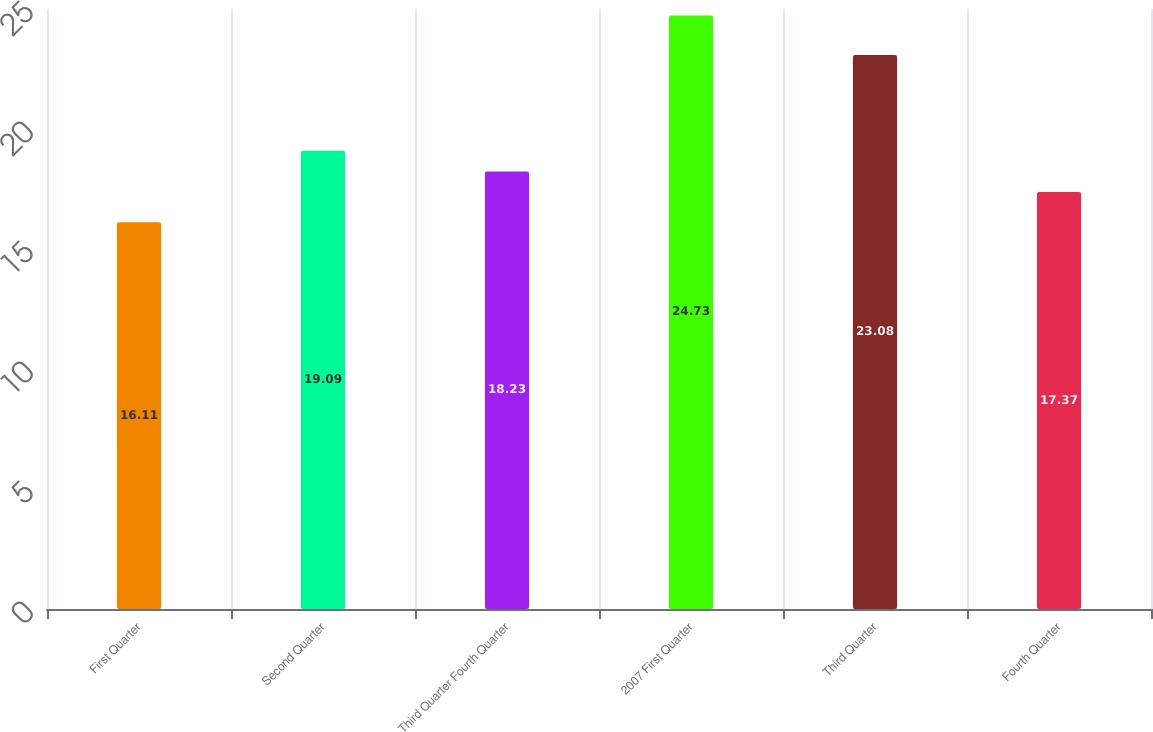<chart> <loc_0><loc_0><loc_500><loc_500><bar_chart><fcel>First Quarter<fcel>Second Quarter<fcel>Third Quarter Fourth Quarter<fcel>2007 First Quarter<fcel>Third Quarter<fcel>Fourth Quarter<nl><fcel>16.11<fcel>19.09<fcel>18.23<fcel>24.73<fcel>23.08<fcel>17.37<nl></chart> 